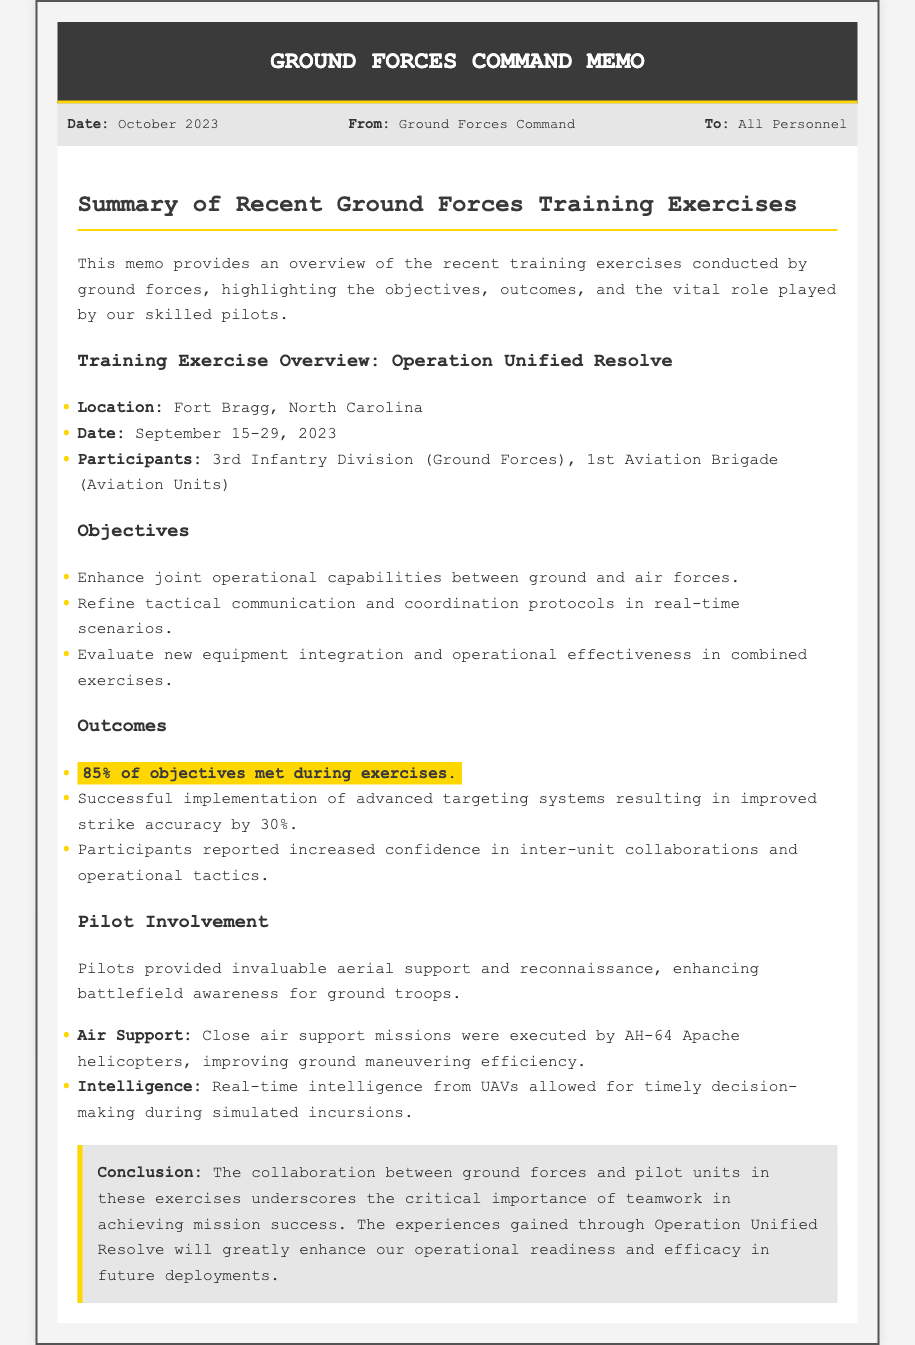What was the location of Operation Unified Resolve? The location stated in the memo for Operation Unified Resolve is where the training exercises took place, which is Fort Bragg, North Carolina.
Answer: Fort Bragg, North Carolina What were the dates of the training exercises? The memo specifies the exact dates when the training exercises were conducted, which are September 15-29, 2023.
Answer: September 15-29, 2023 What percentage of objectives were met during the exercises? The document mentions a specific success rate for our objectives, indicating that 85% of objectives were met during the exercises.
Answer: 85% Which unit provided aerial support? The memo lists the aviation unit involved in the training exercises, which is the 1st Aviation Brigade.
Answer: 1st Aviation Brigade How did the advanced targeting systems impact strike accuracy? The outcomes section of the memo details the improvement achieved through new technology, asserting that strike accuracy improved by 30%.
Answer: 30% What is a key benefit reported by participants? The memo reports increased confidence in a certain area following the exercises, highlighting 'increased confidence in inter-unit collaborations and operational tactics' as a benefit.
Answer: Increased confidence What type of aircraft was used for close air support? The document specifies which aircraft were involved in close air support, identifying the AH-64 Apache helicopters as the key asset.
Answer: AH-64 Apache What was the main focus of the training exercises? The memo outlines the main aim of the exercises, emphasizing the enhancement of joint operational capabilities between ground and air forces.
Answer: Enhance joint operational capabilities 